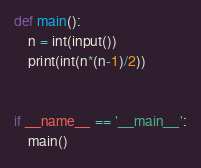<code> <loc_0><loc_0><loc_500><loc_500><_Python_>def main():
    n = int(input())
    print(int(n*(n-1)/2))


if __name__ == '__main__':
    main()
</code> 